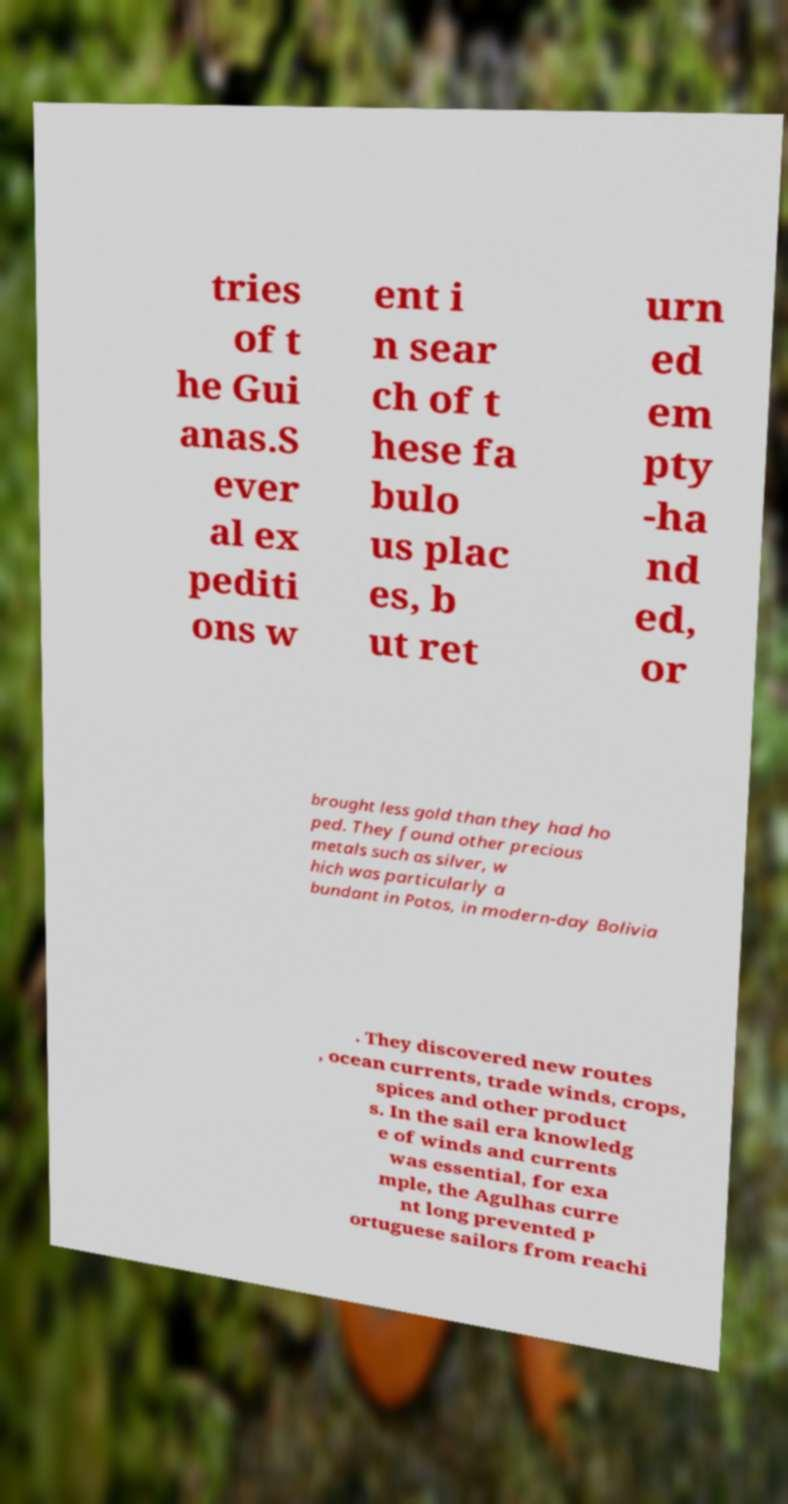I need the written content from this picture converted into text. Can you do that? tries of t he Gui anas.S ever al ex pediti ons w ent i n sear ch of t hese fa bulo us plac es, b ut ret urn ed em pty -ha nd ed, or brought less gold than they had ho ped. They found other precious metals such as silver, w hich was particularly a bundant in Potos, in modern-day Bolivia . They discovered new routes , ocean currents, trade winds, crops, spices and other product s. In the sail era knowledg e of winds and currents was essential, for exa mple, the Agulhas curre nt long prevented P ortuguese sailors from reachi 